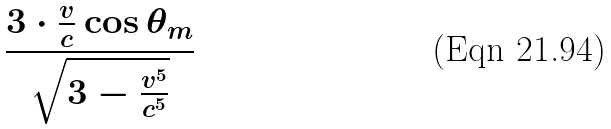Convert formula to latex. <formula><loc_0><loc_0><loc_500><loc_500>\frac { 3 \cdot \frac { v } { c } \cos \theta _ { m } } { \sqrt { 3 - \frac { v ^ { 5 } } { c ^ { 5 } } } }</formula> 